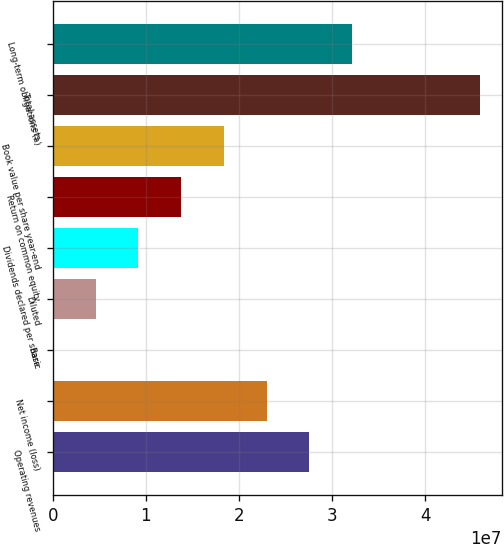Convert chart. <chart><loc_0><loc_0><loc_500><loc_500><bar_chart><fcel>Operating revenues<fcel>Net income (loss)<fcel>Basic<fcel>Diluted<fcel>Dividends declared per share<fcel>Return on common equity<fcel>Book value per share year-end<fcel>Total assets<fcel>Long-term obligations (a)<nl><fcel>2.75427e+07<fcel>2.29522e+07<fcel>3.26<fcel>4.59045e+06<fcel>9.18089e+06<fcel>1.37713e+07<fcel>1.83618e+07<fcel>4.59044e+07<fcel>3.21331e+07<nl></chart> 